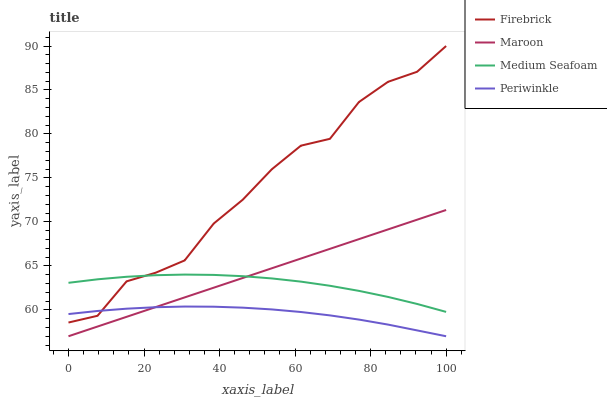Does Periwinkle have the minimum area under the curve?
Answer yes or no. Yes. Does Firebrick have the maximum area under the curve?
Answer yes or no. Yes. Does Medium Seafoam have the minimum area under the curve?
Answer yes or no. No. Does Medium Seafoam have the maximum area under the curve?
Answer yes or no. No. Is Maroon the smoothest?
Answer yes or no. Yes. Is Firebrick the roughest?
Answer yes or no. Yes. Is Periwinkle the smoothest?
Answer yes or no. No. Is Periwinkle the roughest?
Answer yes or no. No. Does Medium Seafoam have the lowest value?
Answer yes or no. No. Does Medium Seafoam have the highest value?
Answer yes or no. No. Is Periwinkle less than Medium Seafoam?
Answer yes or no. Yes. Is Medium Seafoam greater than Periwinkle?
Answer yes or no. Yes. Does Periwinkle intersect Medium Seafoam?
Answer yes or no. No. 